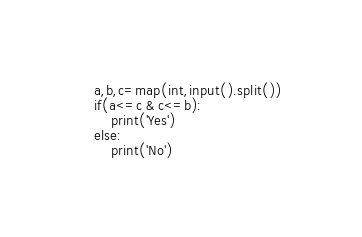<code> <loc_0><loc_0><loc_500><loc_500><_Python_>a,b,c=map(int,input().split())
if(a<=c & c<=b):
    print('Yes')
else:
    print('No')</code> 